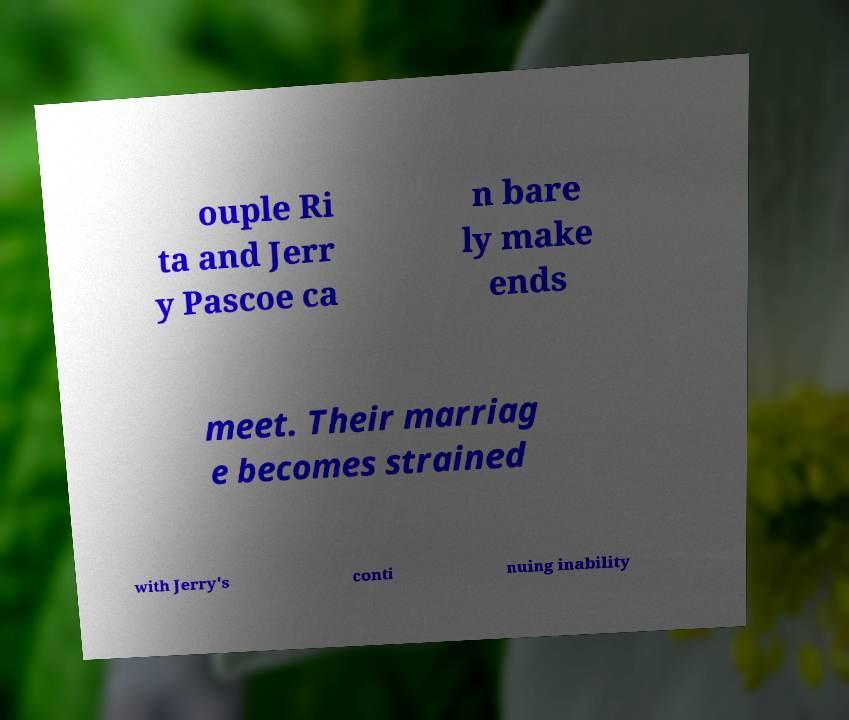Can you read and provide the text displayed in the image?This photo seems to have some interesting text. Can you extract and type it out for me? ouple Ri ta and Jerr y Pascoe ca n bare ly make ends meet. Their marriag e becomes strained with Jerry's conti nuing inability 